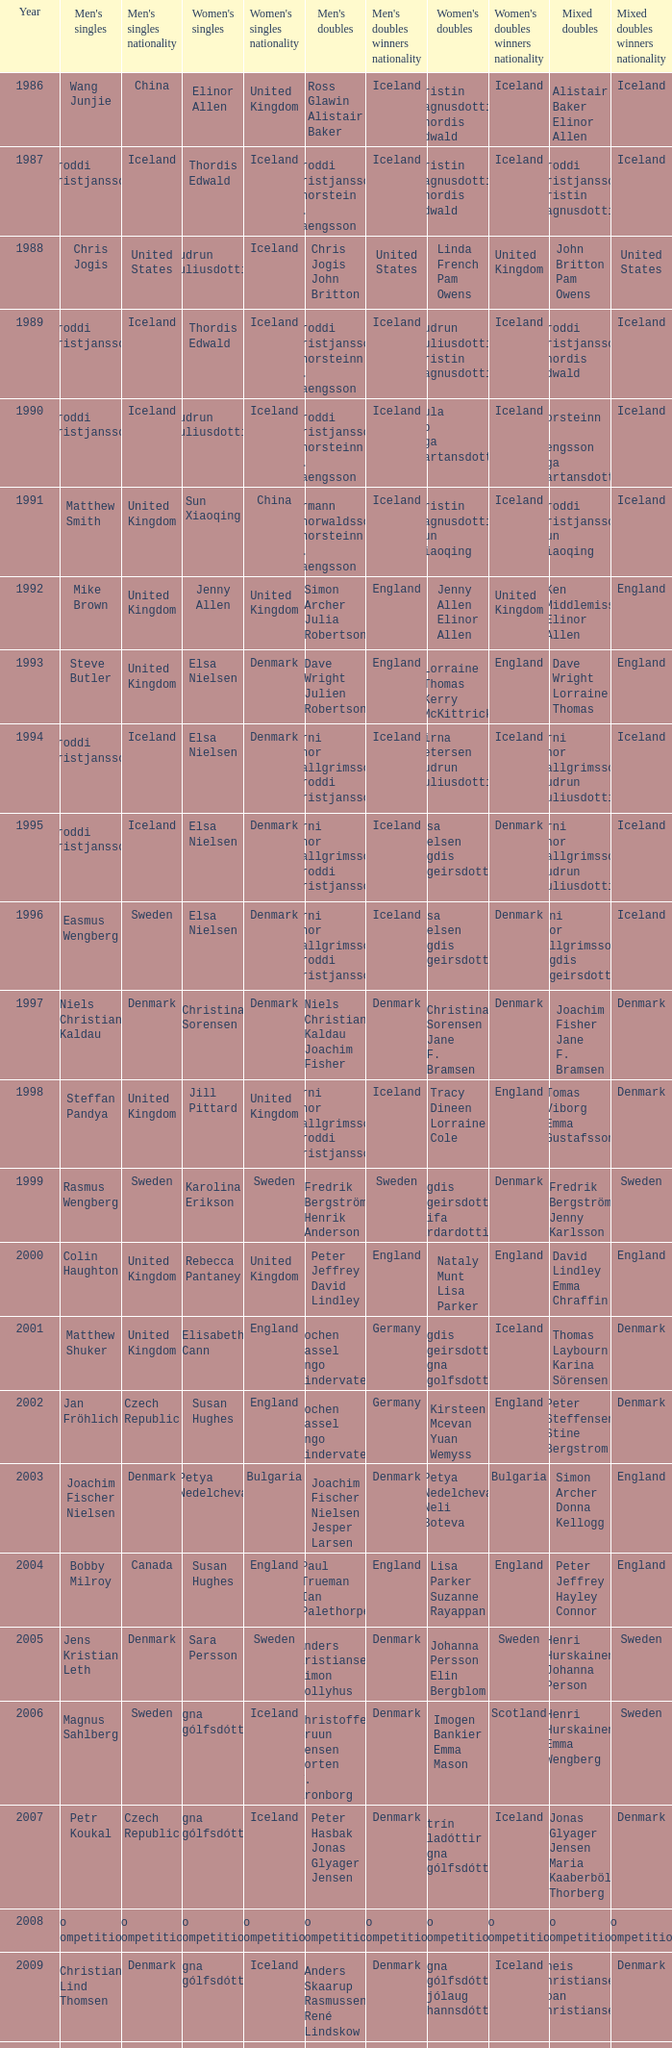In which women's doubles did Wang Junjie play men's singles? Kristin Magnusdottir Thordis Edwald. 